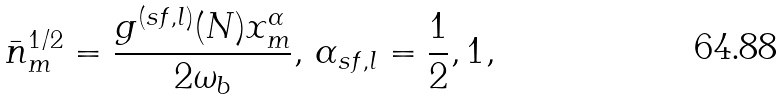Convert formula to latex. <formula><loc_0><loc_0><loc_500><loc_500>\bar { n } _ { m } ^ { 1 / 2 } = \frac { g ^ { ( s f , l ) } ( N ) x _ { m } ^ { \alpha } } { 2 \omega _ { b } } , \, \alpha _ { s f , l } = \frac { 1 } { 2 } , 1 ,</formula> 